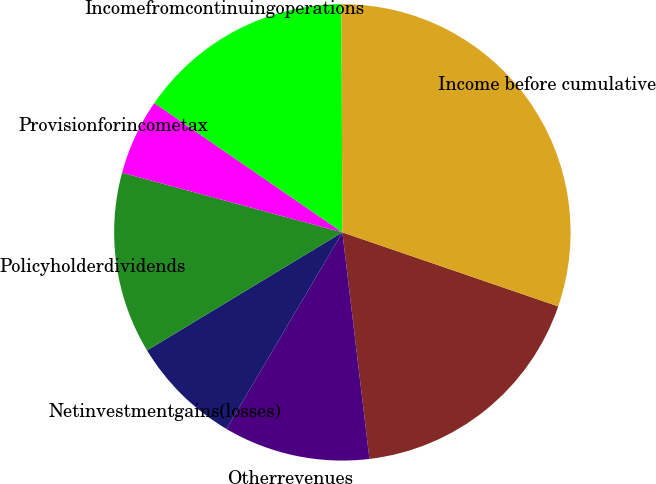<chart> <loc_0><loc_0><loc_500><loc_500><pie_chart><ecel><fcel>Otherrevenues<fcel>Netinvestmentgains(losses)<fcel>Policyholderdividends<fcel>Provisionforincometax<fcel>Incomefromcontinuingoperations<fcel>Income before cumulative<nl><fcel>17.85%<fcel>10.37%<fcel>7.87%<fcel>12.86%<fcel>5.38%<fcel>15.35%<fcel>30.32%<nl></chart> 